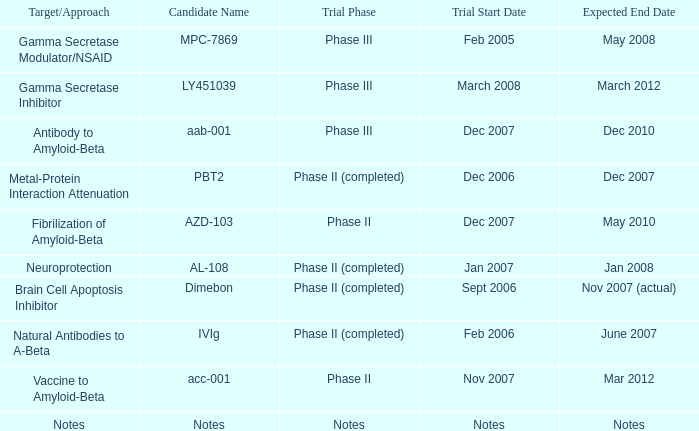For the candidate pbt2, what is the start date of the trial? Dec 2006. 